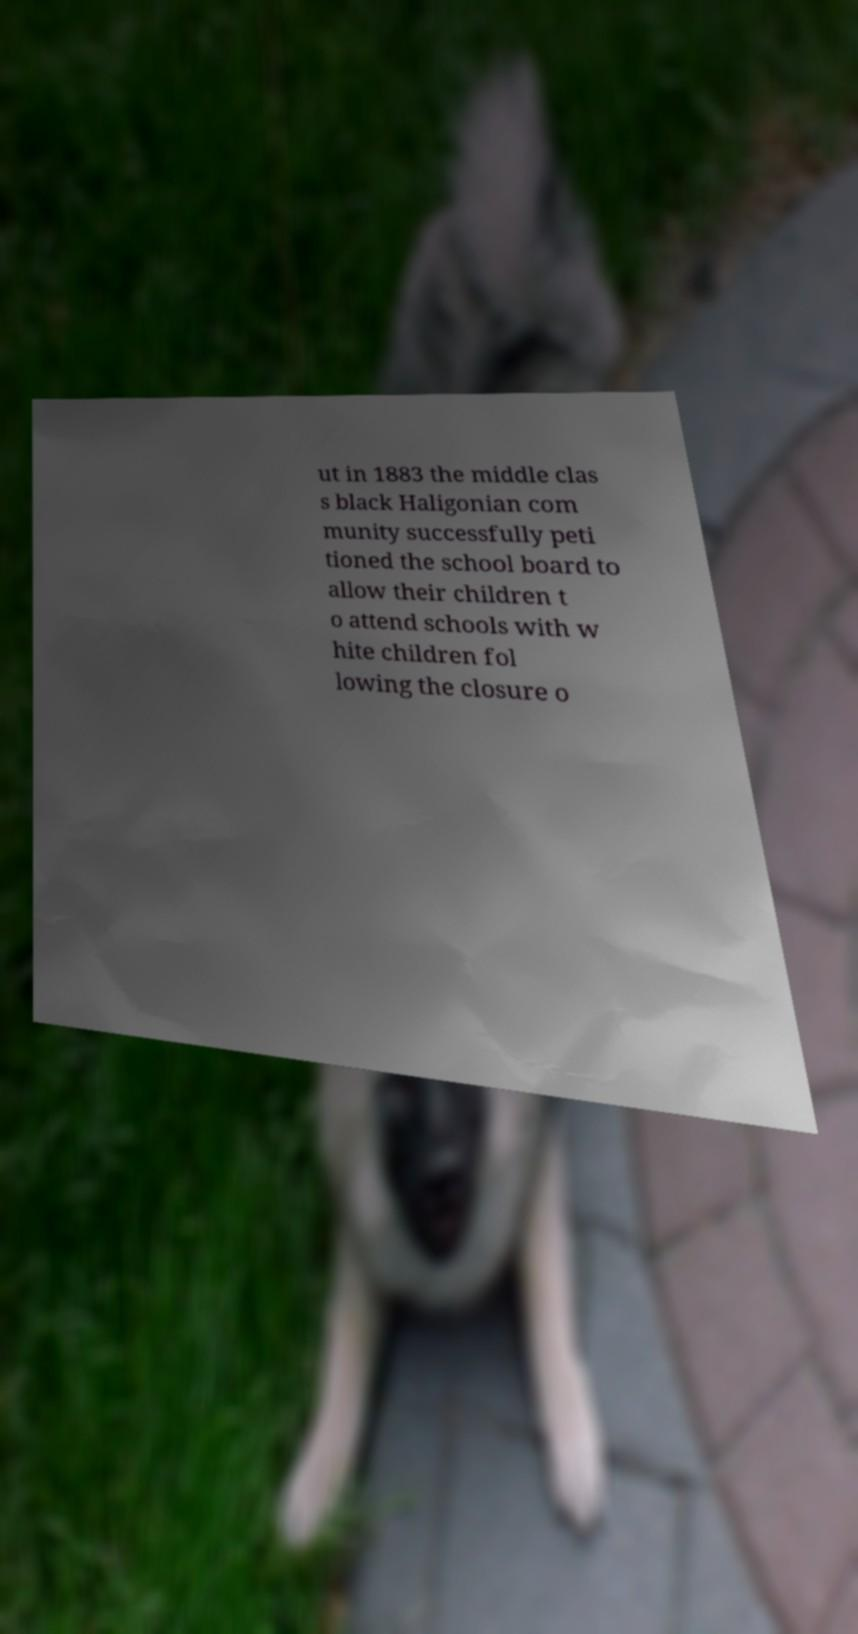Could you extract and type out the text from this image? ut in 1883 the middle clas s black Haligonian com munity successfully peti tioned the school board to allow their children t o attend schools with w hite children fol lowing the closure o 